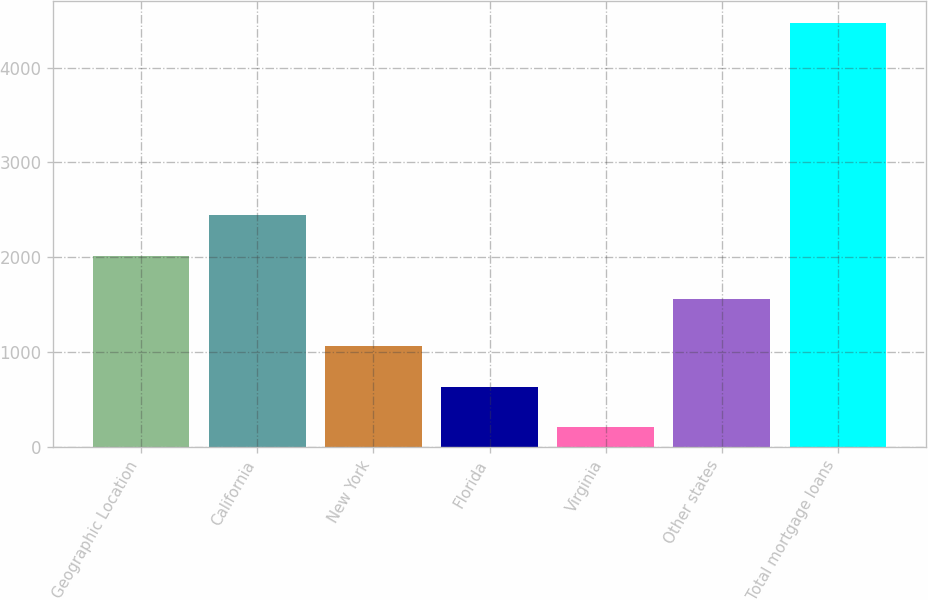<chart> <loc_0><loc_0><loc_500><loc_500><bar_chart><fcel>Geographic Location<fcel>California<fcel>New York<fcel>Florida<fcel>Virginia<fcel>Other states<fcel>Total mortgage loans<nl><fcel>2013<fcel>2439.93<fcel>1059.36<fcel>632.43<fcel>205.5<fcel>1557.1<fcel>4474.8<nl></chart> 